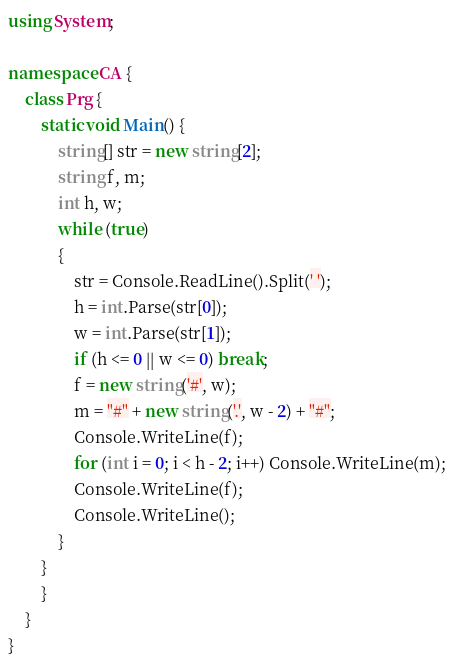Convert code to text. <code><loc_0><loc_0><loc_500><loc_500><_C#_>using System;

namespace CA {
	class Prg {
		static void Main() {
			string[] str = new string[2];
			string f, m;
			int h, w;
			while (true)
            {
                str = Console.ReadLine().Split(' ');
                h = int.Parse(str[0]);
                w = int.Parse(str[1]);
                if (h <= 0 || w <= 0) break;
                f = new string('#', w);
				m = "#" + new string('.', w - 2) + "#";
                Console.WriteLine(f);
                for (int i = 0; i < h - 2; i++) Console.WriteLine(m);
                Console.WriteLine(f);
                Console.WriteLine();
            }
        }
		}
	}
}</code> 